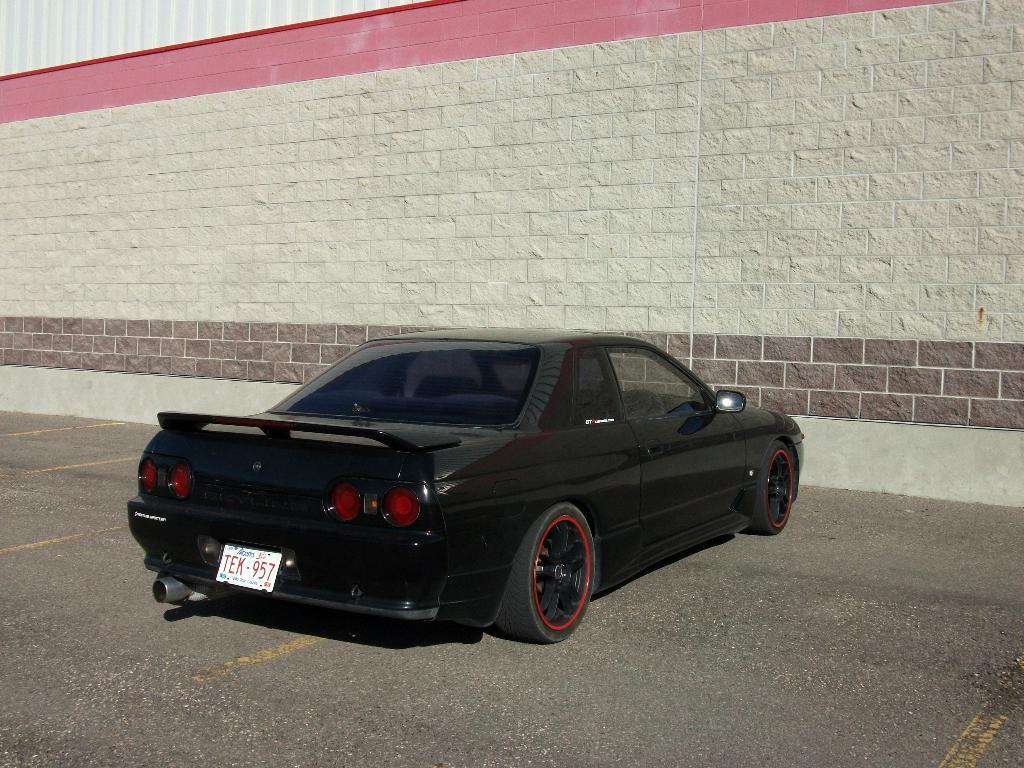What is the main subject in the foreground of the image? There is a car in the foreground of the image. What is the position of the car in the image? The car is parked on the ground. What can be seen in the background of the image? There is a wall visible in the background of the image. What type of bomb is being diffused near the car in the image? There is no bomb present in the image; it only features a parked car and a wall in the background. 